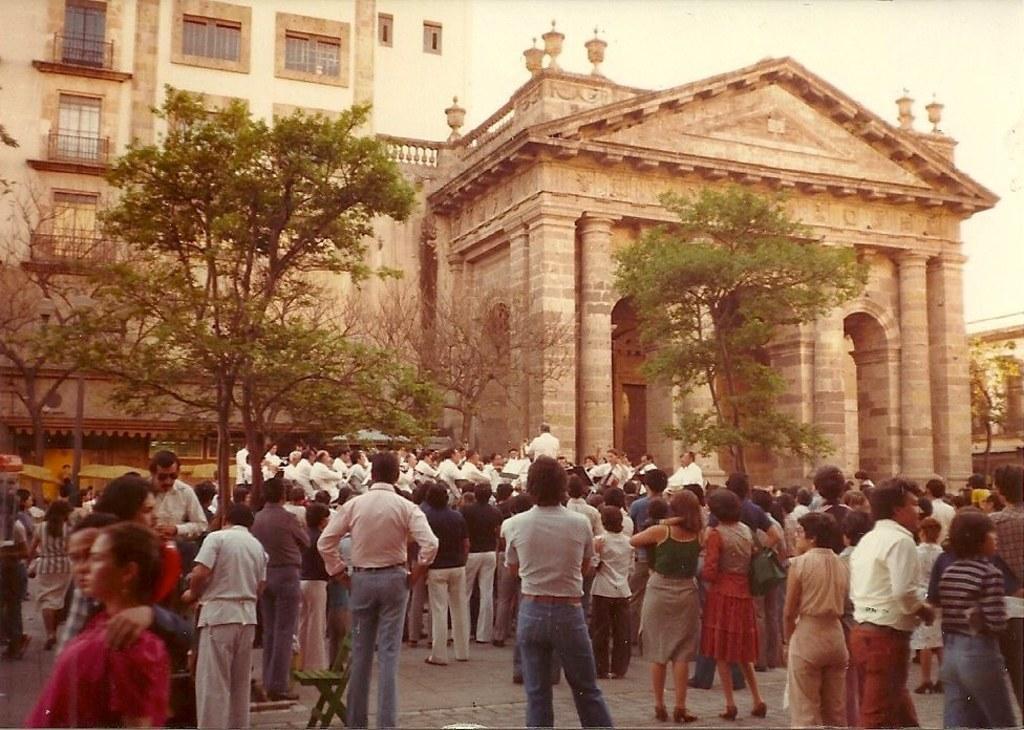Can you describe this image briefly? In the foreground of this image, there are people standing and walking on the pavement. We can also see a chair, few trees, buildings and the sky. 